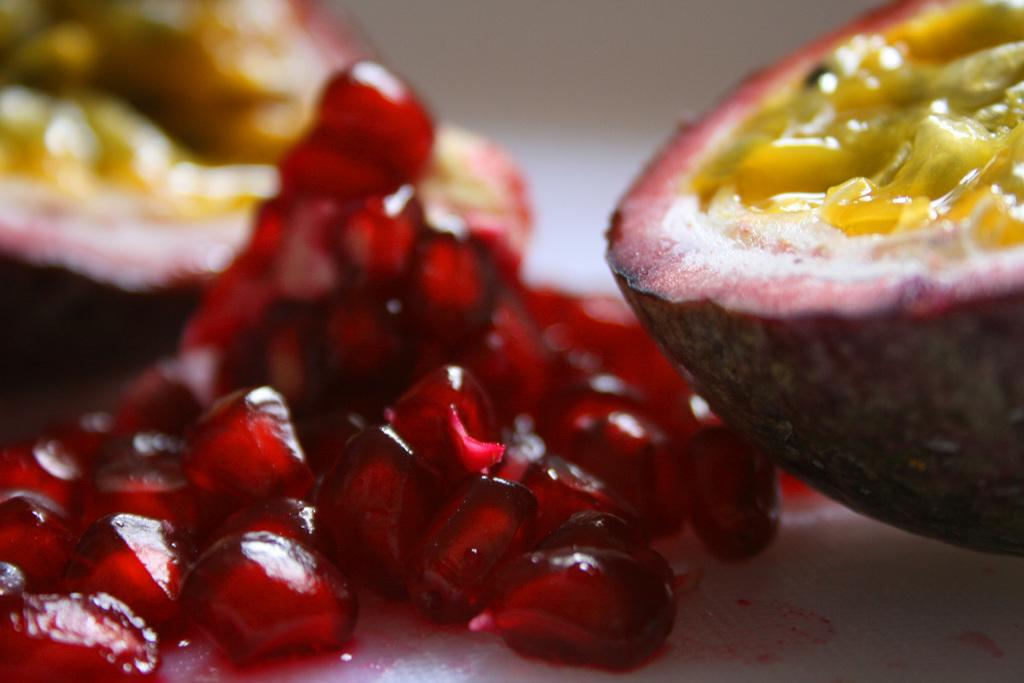What type of objects are present in the image? There is a group of fruits in the image. Can you describe the fruits in the image? The specific types of fruits cannot be determined from the provided facts, but they are a group of fruits. How many fruits are in the group? The number of fruits in the group cannot be determined from the provided facts. What type of scale is used to weigh the grandfather in the image? There is no grandfather or scale present in the image; it only contains a group of fruits. 